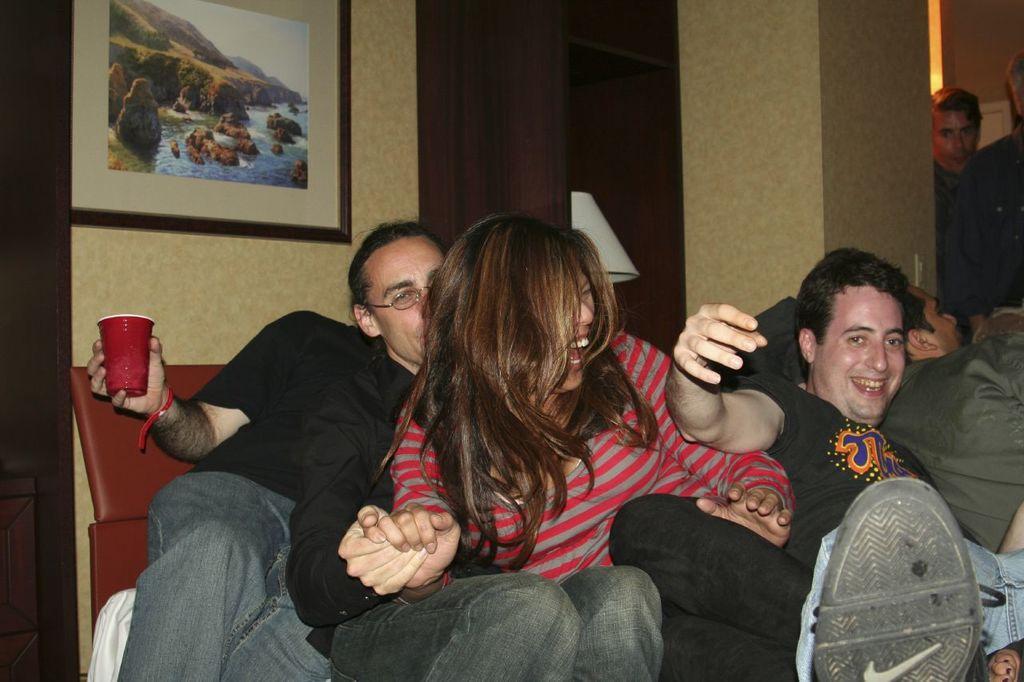Can you describe this image briefly? In this picture we can observe some people in sitting. There are men and a woman. We can observe a photo frame fixed to the wall. There is a brown color cupboard and a lamp in the background. 